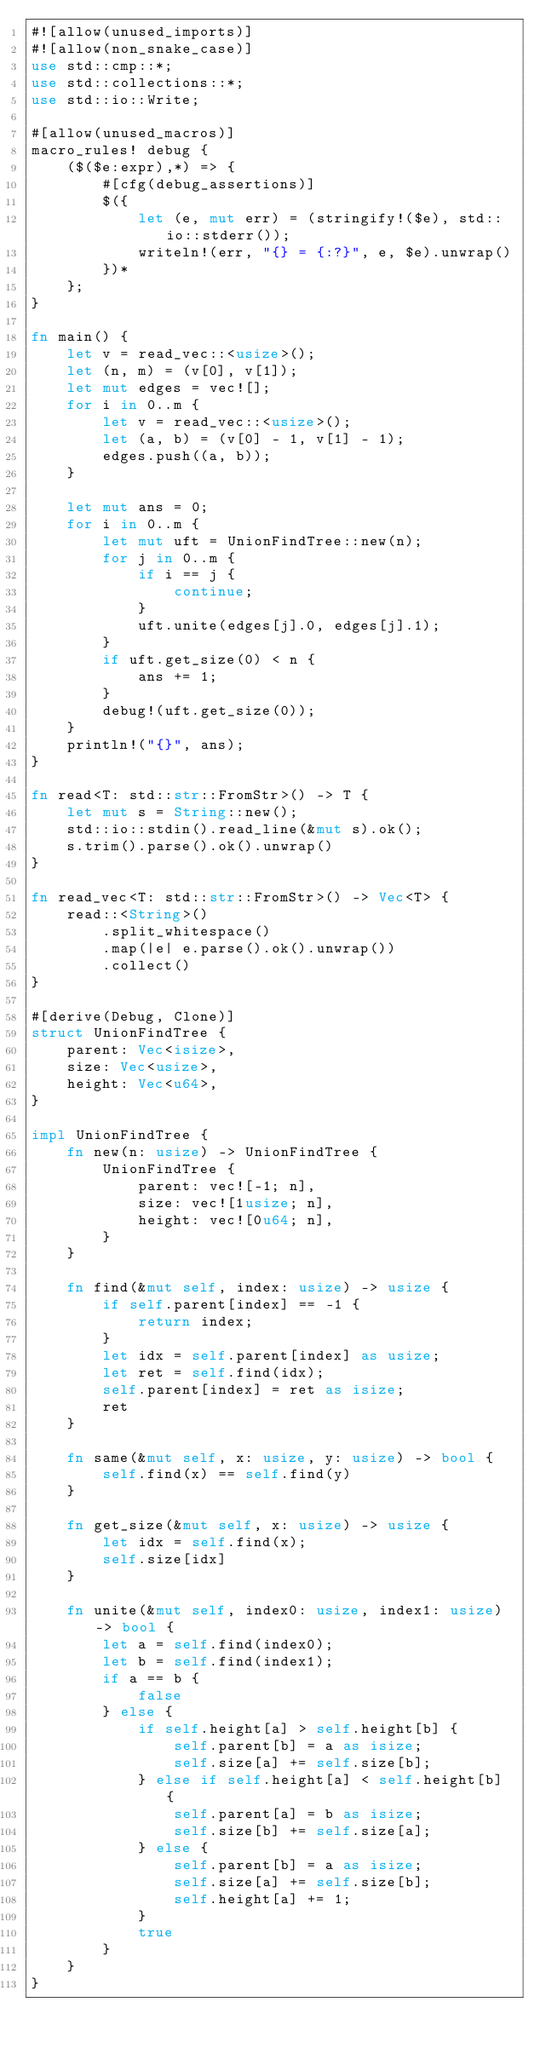Convert code to text. <code><loc_0><loc_0><loc_500><loc_500><_Rust_>#![allow(unused_imports)]
#![allow(non_snake_case)]
use std::cmp::*;
use std::collections::*;
use std::io::Write;

#[allow(unused_macros)]
macro_rules! debug {
    ($($e:expr),*) => {
        #[cfg(debug_assertions)]
        $({
            let (e, mut err) = (stringify!($e), std::io::stderr());
            writeln!(err, "{} = {:?}", e, $e).unwrap()
        })*
    };
}

fn main() {
    let v = read_vec::<usize>();
    let (n, m) = (v[0], v[1]);
    let mut edges = vec![];
    for i in 0..m {
        let v = read_vec::<usize>();
        let (a, b) = (v[0] - 1, v[1] - 1);
        edges.push((a, b));
    }

    let mut ans = 0;
    for i in 0..m {
        let mut uft = UnionFindTree::new(n);
        for j in 0..m {
            if i == j {
                continue;
            }
            uft.unite(edges[j].0, edges[j].1);
        }
        if uft.get_size(0) < n {
            ans += 1;
        }
        debug!(uft.get_size(0));
    }
    println!("{}", ans);
}

fn read<T: std::str::FromStr>() -> T {
    let mut s = String::new();
    std::io::stdin().read_line(&mut s).ok();
    s.trim().parse().ok().unwrap()
}

fn read_vec<T: std::str::FromStr>() -> Vec<T> {
    read::<String>()
        .split_whitespace()
        .map(|e| e.parse().ok().unwrap())
        .collect()
}

#[derive(Debug, Clone)]
struct UnionFindTree {
    parent: Vec<isize>,
    size: Vec<usize>,
    height: Vec<u64>,
}

impl UnionFindTree {
    fn new(n: usize) -> UnionFindTree {
        UnionFindTree {
            parent: vec![-1; n],
            size: vec![1usize; n],
            height: vec![0u64; n],
        }
    }

    fn find(&mut self, index: usize) -> usize {
        if self.parent[index] == -1 {
            return index;
        }
        let idx = self.parent[index] as usize;
        let ret = self.find(idx);
        self.parent[index] = ret as isize;
        ret
    }

    fn same(&mut self, x: usize, y: usize) -> bool {
        self.find(x) == self.find(y)
    }

    fn get_size(&mut self, x: usize) -> usize {
        let idx = self.find(x);
        self.size[idx]
    }

    fn unite(&mut self, index0: usize, index1: usize) -> bool {
        let a = self.find(index0);
        let b = self.find(index1);
        if a == b {
            false
        } else {
            if self.height[a] > self.height[b] {
                self.parent[b] = a as isize;
                self.size[a] += self.size[b];
            } else if self.height[a] < self.height[b] {
                self.parent[a] = b as isize;
                self.size[b] += self.size[a];
            } else {
                self.parent[b] = a as isize;
                self.size[a] += self.size[b];
                self.height[a] += 1;
            }
            true
        }
    }
}
</code> 